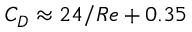<formula> <loc_0><loc_0><loc_500><loc_500>C _ { D } \approx 2 4 / R e + 0 . 3 5</formula> 